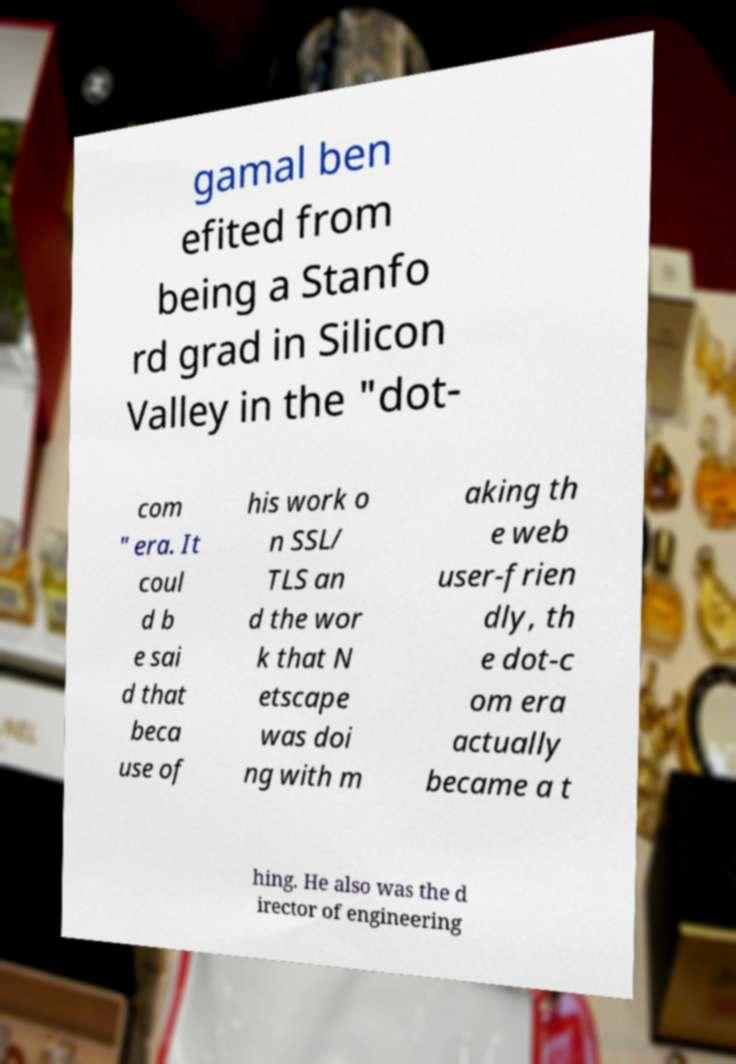Can you accurately transcribe the text from the provided image for me? gamal ben efited from being a Stanfo rd grad in Silicon Valley in the "dot- com " era. It coul d b e sai d that beca use of his work o n SSL/ TLS an d the wor k that N etscape was doi ng with m aking th e web user-frien dly, th e dot-c om era actually became a t hing. He also was the d irector of engineering 